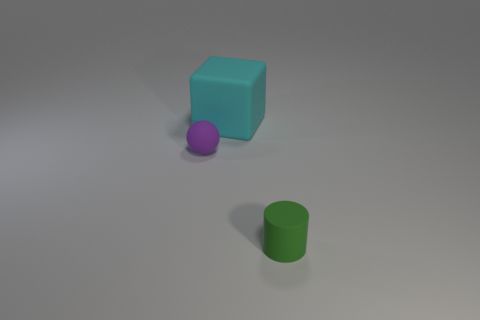There is a ball that is made of the same material as the small green cylinder; what size is it?
Make the answer very short. Small. What material is the object that is the same size as the green rubber cylinder?
Ensure brevity in your answer.  Rubber. Is there another big block made of the same material as the big block?
Provide a short and direct response. No. What is the color of the rubber object that is in front of the cyan block and to the left of the green rubber cylinder?
Your answer should be very brief. Purple. What is the material of the object that is behind the small object left of the rubber thing that is behind the small purple thing?
Offer a terse response. Rubber. What number of cylinders are small rubber things or large cyan objects?
Your answer should be compact. 1. Is there any other thing that has the same size as the green cylinder?
Your answer should be very brief. Yes. There is a small matte object to the left of the matte object in front of the tiny sphere; how many matte things are right of it?
Give a very brief answer. 2. Is the shape of the cyan matte object the same as the green matte object?
Provide a short and direct response. No. Is the small thing on the left side of the rubber cube made of the same material as the object that is on the right side of the big cyan object?
Your response must be concise. Yes. 